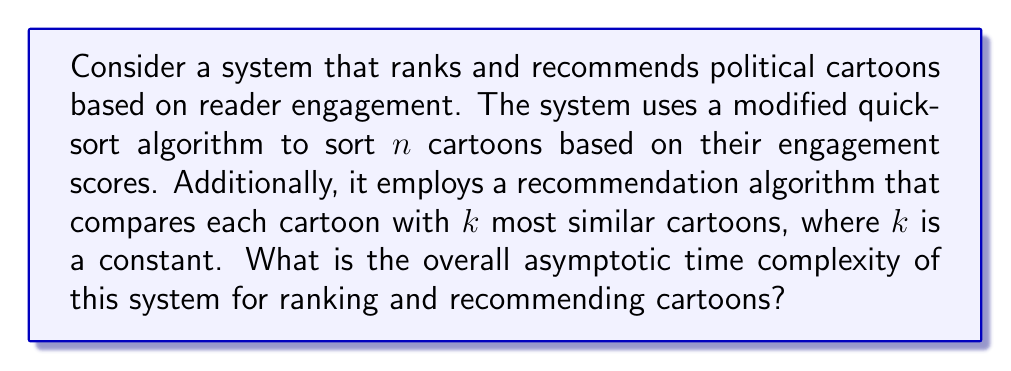Teach me how to tackle this problem. To determine the overall asymptotic time complexity, we need to analyze both the ranking and recommendation components:

1. Ranking component (modified quicksort):
   The average-case time complexity of quicksort is $O(n \log n)$, where $n$ is the number of cartoons.

2. Recommendation component:
   For each cartoon, the system compares it with $k$ most similar cartoons. Since $k$ is a constant, this operation takes $O(1)$ time for each cartoon. As we perform this for all $n$ cartoons, the total time complexity for the recommendation component is $O(n)$.

3. Overall complexity:
   The overall time complexity is the sum of the complexities of both components:
   $O(n \log n) + O(n)$

   In asymptotic analysis, we focus on the dominant term. Since $n \log n$ grows faster than $n$ for large values of $n$, we can simplify the expression to:
   $O(n \log n)$

Therefore, the overall asymptotic time complexity of the system is $O(n \log n)$.
Answer: $O(n \log n)$ 